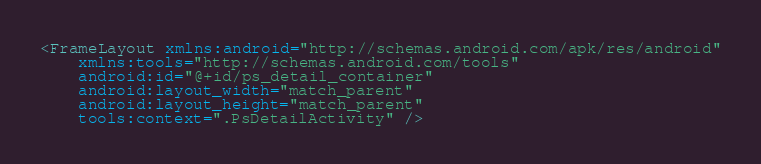Convert code to text. <code><loc_0><loc_0><loc_500><loc_500><_XML_><FrameLayout xmlns:android="http://schemas.android.com/apk/res/android"
    xmlns:tools="http://schemas.android.com/tools"
    android:id="@+id/ps_detail_container"
    android:layout_width="match_parent"
    android:layout_height="match_parent"
    tools:context=".PsDetailActivity" />
</code> 